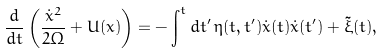Convert formula to latex. <formula><loc_0><loc_0><loc_500><loc_500>\frac { d } { d t } \left ( \frac { \dot { x } ^ { 2 } } { 2 \Omega } + U ( x ) \right ) = - \int ^ { t } d t ^ { \prime } \, \eta ( t , t ^ { \prime } ) \dot { x } ( t ) \dot { x } ( t ^ { \prime } ) + \tilde { \xi } ( t ) ,</formula> 